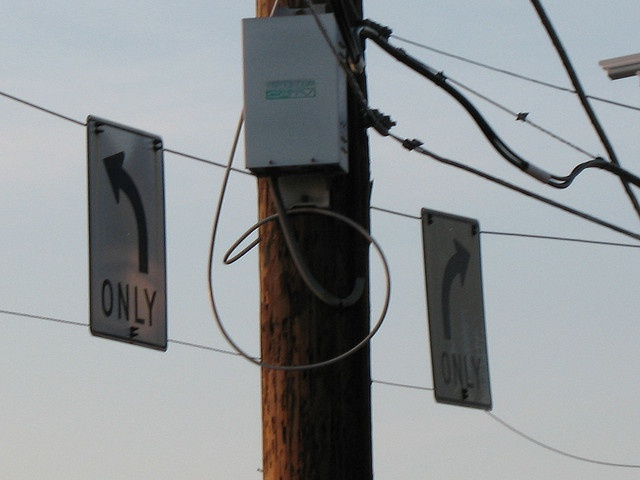Describe the objects in this image and their specific colors. I can see various objects in this image with different colors. 